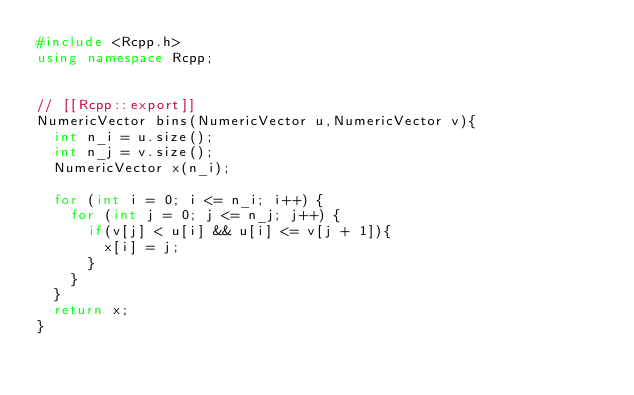<code> <loc_0><loc_0><loc_500><loc_500><_C++_>#include <Rcpp.h>
using namespace Rcpp;


// [[Rcpp::export]]
NumericVector bins(NumericVector u,NumericVector v){
  int n_i = u.size();
  int n_j = v.size();
  NumericVector x(n_i);
  
  for (int i = 0; i <= n_i; i++) {
    for (int j = 0; j <= n_j; j++) {
      if(v[j] < u[i] && u[i] <= v[j + 1]){
        x[i] = j;
      }
    }
  } 
  return x;
}</code> 